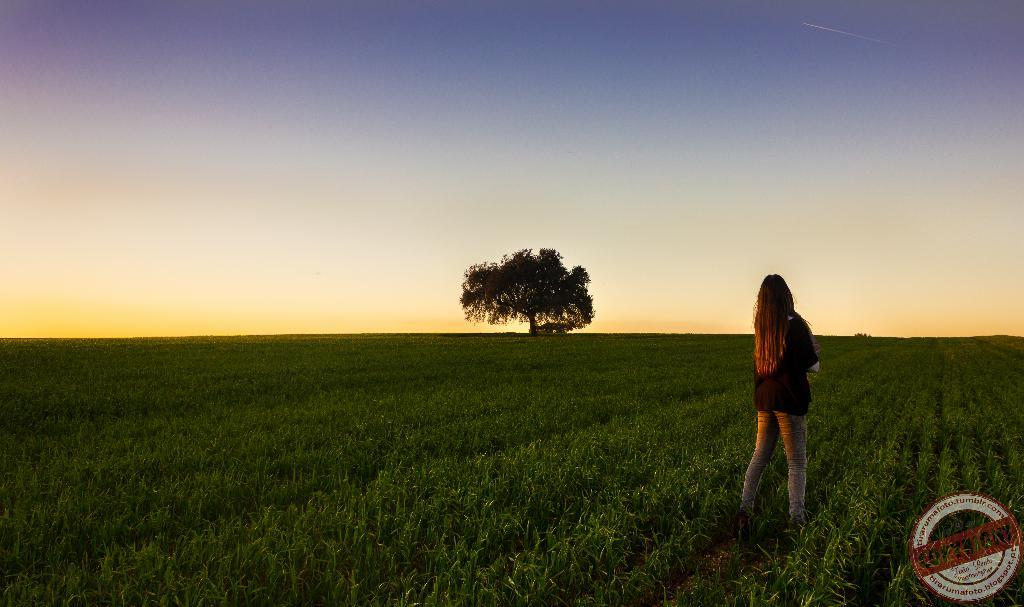Who is present in the image? There is a woman in the image. What is the woman doing in the image? The woman is standing in a crop. What is the woman wearing in the image? The woman is wearing a black top. What can be seen in the middle of the image? There is a tree in the middle of the image. What is visible at the top of the image? The sky is visible at the top of the image. What else can be observed on the image? There is a watermark on the right side of the image. How does the woman comfort the ducks in the image? There are no ducks present in the image, so the woman cannot comfort any ducks. 